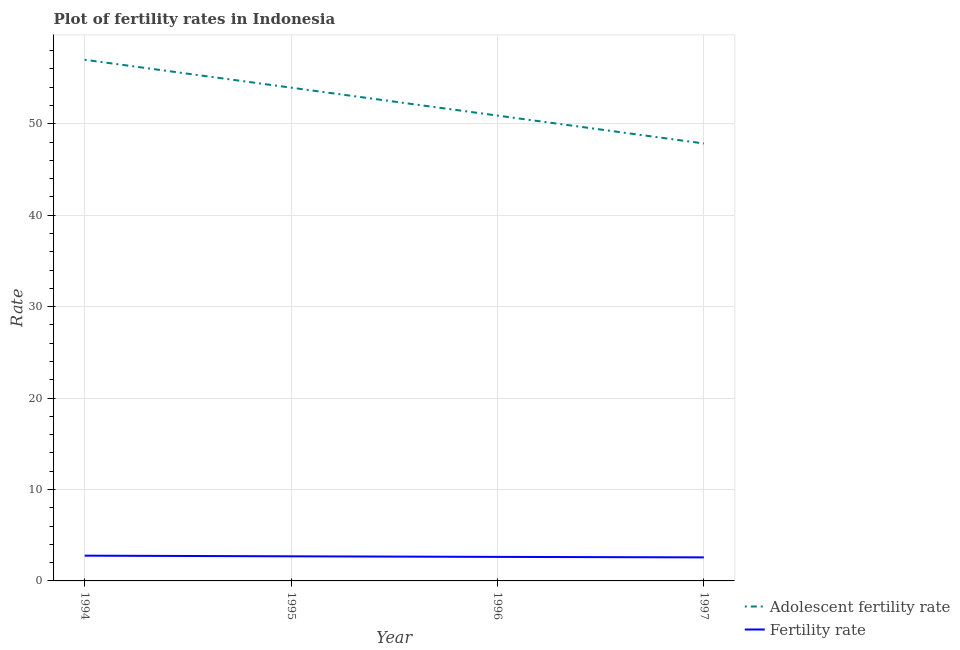How many different coloured lines are there?
Offer a terse response. 2. Is the number of lines equal to the number of legend labels?
Give a very brief answer. Yes. What is the fertility rate in 1995?
Your answer should be very brief. 2.69. Across all years, what is the maximum fertility rate?
Make the answer very short. 2.76. Across all years, what is the minimum fertility rate?
Your response must be concise. 2.58. In which year was the adolescent fertility rate minimum?
Provide a short and direct response. 1997. What is the total adolescent fertility rate in the graph?
Offer a terse response. 209.71. What is the difference between the adolescent fertility rate in 1995 and that in 1997?
Your answer should be compact. 6.1. What is the difference between the fertility rate in 1996 and the adolescent fertility rate in 1995?
Provide a succinct answer. -51.32. What is the average adolescent fertility rate per year?
Make the answer very short. 52.43. In the year 1995, what is the difference between the fertility rate and adolescent fertility rate?
Keep it short and to the point. -51.26. What is the ratio of the fertility rate in 1994 to that in 1997?
Offer a terse response. 1.07. What is the difference between the highest and the second highest adolescent fertility rate?
Provide a succinct answer. 3.05. What is the difference between the highest and the lowest fertility rate?
Keep it short and to the point. 0.19. In how many years, is the fertility rate greater than the average fertility rate taken over all years?
Keep it short and to the point. 2. Is the sum of the fertility rate in 1995 and 1997 greater than the maximum adolescent fertility rate across all years?
Ensure brevity in your answer.  No. Does the adolescent fertility rate monotonically increase over the years?
Offer a terse response. No. How many lines are there?
Your answer should be compact. 2. How many years are there in the graph?
Keep it short and to the point. 4. What is the difference between two consecutive major ticks on the Y-axis?
Provide a succinct answer. 10. Are the values on the major ticks of Y-axis written in scientific E-notation?
Offer a very short reply. No. Does the graph contain any zero values?
Your response must be concise. No. Does the graph contain grids?
Provide a short and direct response. Yes. Where does the legend appear in the graph?
Make the answer very short. Bottom right. How many legend labels are there?
Ensure brevity in your answer.  2. What is the title of the graph?
Keep it short and to the point. Plot of fertility rates in Indonesia. Does "Non-resident workers" appear as one of the legend labels in the graph?
Your answer should be compact. No. What is the label or title of the X-axis?
Provide a succinct answer. Year. What is the label or title of the Y-axis?
Your answer should be compact. Rate. What is the Rate in Adolescent fertility rate in 1994?
Give a very brief answer. 57.01. What is the Rate in Fertility rate in 1994?
Ensure brevity in your answer.  2.76. What is the Rate in Adolescent fertility rate in 1995?
Offer a very short reply. 53.95. What is the Rate of Fertility rate in 1995?
Provide a succinct answer. 2.69. What is the Rate of Adolescent fertility rate in 1996?
Give a very brief answer. 50.9. What is the Rate in Fertility rate in 1996?
Give a very brief answer. 2.63. What is the Rate of Adolescent fertility rate in 1997?
Provide a succinct answer. 47.85. What is the Rate in Fertility rate in 1997?
Ensure brevity in your answer.  2.58. Across all years, what is the maximum Rate of Adolescent fertility rate?
Offer a terse response. 57.01. Across all years, what is the maximum Rate in Fertility rate?
Your answer should be very brief. 2.76. Across all years, what is the minimum Rate in Adolescent fertility rate?
Offer a very short reply. 47.85. Across all years, what is the minimum Rate in Fertility rate?
Offer a terse response. 2.58. What is the total Rate of Adolescent fertility rate in the graph?
Provide a succinct answer. 209.71. What is the total Rate of Fertility rate in the graph?
Provide a short and direct response. 10.66. What is the difference between the Rate in Adolescent fertility rate in 1994 and that in 1995?
Keep it short and to the point. 3.05. What is the difference between the Rate of Fertility rate in 1994 and that in 1995?
Make the answer very short. 0.07. What is the difference between the Rate of Adolescent fertility rate in 1994 and that in 1996?
Provide a short and direct response. 6.1. What is the difference between the Rate in Fertility rate in 1994 and that in 1996?
Keep it short and to the point. 0.14. What is the difference between the Rate of Adolescent fertility rate in 1994 and that in 1997?
Keep it short and to the point. 9.16. What is the difference between the Rate of Fertility rate in 1994 and that in 1997?
Make the answer very short. 0.19. What is the difference between the Rate of Adolescent fertility rate in 1995 and that in 1996?
Your response must be concise. 3.05. What is the difference between the Rate in Fertility rate in 1995 and that in 1996?
Your answer should be compact. 0.06. What is the difference between the Rate in Adolescent fertility rate in 1995 and that in 1997?
Offer a terse response. 6.1. What is the difference between the Rate of Fertility rate in 1995 and that in 1997?
Ensure brevity in your answer.  0.12. What is the difference between the Rate of Adolescent fertility rate in 1996 and that in 1997?
Your answer should be very brief. 3.05. What is the difference between the Rate of Fertility rate in 1996 and that in 1997?
Your answer should be very brief. 0.05. What is the difference between the Rate of Adolescent fertility rate in 1994 and the Rate of Fertility rate in 1995?
Give a very brief answer. 54.31. What is the difference between the Rate in Adolescent fertility rate in 1994 and the Rate in Fertility rate in 1996?
Your response must be concise. 54.38. What is the difference between the Rate in Adolescent fertility rate in 1994 and the Rate in Fertility rate in 1997?
Offer a very short reply. 54.43. What is the difference between the Rate in Adolescent fertility rate in 1995 and the Rate in Fertility rate in 1996?
Make the answer very short. 51.32. What is the difference between the Rate in Adolescent fertility rate in 1995 and the Rate in Fertility rate in 1997?
Your answer should be compact. 51.38. What is the difference between the Rate of Adolescent fertility rate in 1996 and the Rate of Fertility rate in 1997?
Your answer should be very brief. 48.33. What is the average Rate of Adolescent fertility rate per year?
Ensure brevity in your answer.  52.43. What is the average Rate in Fertility rate per year?
Ensure brevity in your answer.  2.66. In the year 1994, what is the difference between the Rate of Adolescent fertility rate and Rate of Fertility rate?
Your answer should be compact. 54.24. In the year 1995, what is the difference between the Rate of Adolescent fertility rate and Rate of Fertility rate?
Give a very brief answer. 51.26. In the year 1996, what is the difference between the Rate of Adolescent fertility rate and Rate of Fertility rate?
Your answer should be compact. 48.27. In the year 1997, what is the difference between the Rate of Adolescent fertility rate and Rate of Fertility rate?
Give a very brief answer. 45.27. What is the ratio of the Rate of Adolescent fertility rate in 1994 to that in 1995?
Offer a terse response. 1.06. What is the ratio of the Rate in Fertility rate in 1994 to that in 1995?
Give a very brief answer. 1.03. What is the ratio of the Rate of Adolescent fertility rate in 1994 to that in 1996?
Keep it short and to the point. 1.12. What is the ratio of the Rate of Fertility rate in 1994 to that in 1996?
Keep it short and to the point. 1.05. What is the ratio of the Rate of Adolescent fertility rate in 1994 to that in 1997?
Give a very brief answer. 1.19. What is the ratio of the Rate of Fertility rate in 1994 to that in 1997?
Your answer should be very brief. 1.07. What is the ratio of the Rate in Adolescent fertility rate in 1995 to that in 1996?
Offer a terse response. 1.06. What is the ratio of the Rate of Fertility rate in 1995 to that in 1996?
Offer a very short reply. 1.02. What is the ratio of the Rate in Adolescent fertility rate in 1995 to that in 1997?
Keep it short and to the point. 1.13. What is the ratio of the Rate of Fertility rate in 1995 to that in 1997?
Ensure brevity in your answer.  1.04. What is the ratio of the Rate of Adolescent fertility rate in 1996 to that in 1997?
Your answer should be very brief. 1.06. What is the ratio of the Rate in Fertility rate in 1996 to that in 1997?
Provide a short and direct response. 1.02. What is the difference between the highest and the second highest Rate of Adolescent fertility rate?
Your response must be concise. 3.05. What is the difference between the highest and the second highest Rate of Fertility rate?
Your answer should be very brief. 0.07. What is the difference between the highest and the lowest Rate of Adolescent fertility rate?
Provide a succinct answer. 9.16. What is the difference between the highest and the lowest Rate in Fertility rate?
Give a very brief answer. 0.19. 